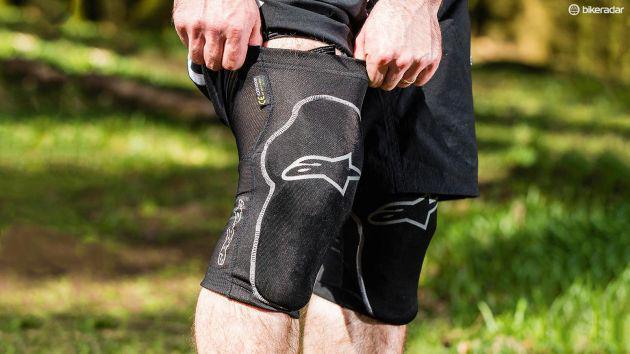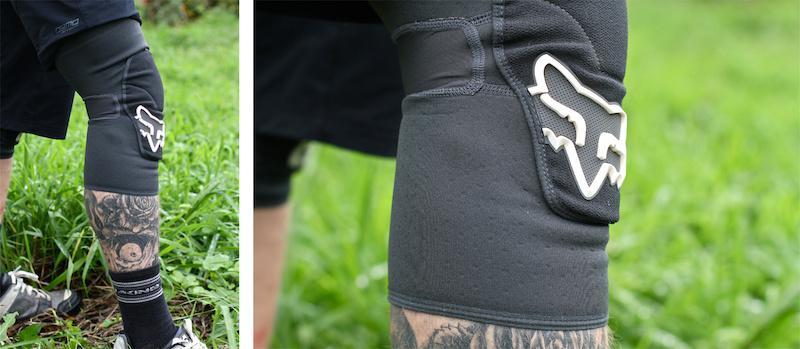The first image is the image on the left, the second image is the image on the right. Evaluate the accuracy of this statement regarding the images: "At least one knee pad is not worn by a human.". Is it true? Answer yes or no. No. 